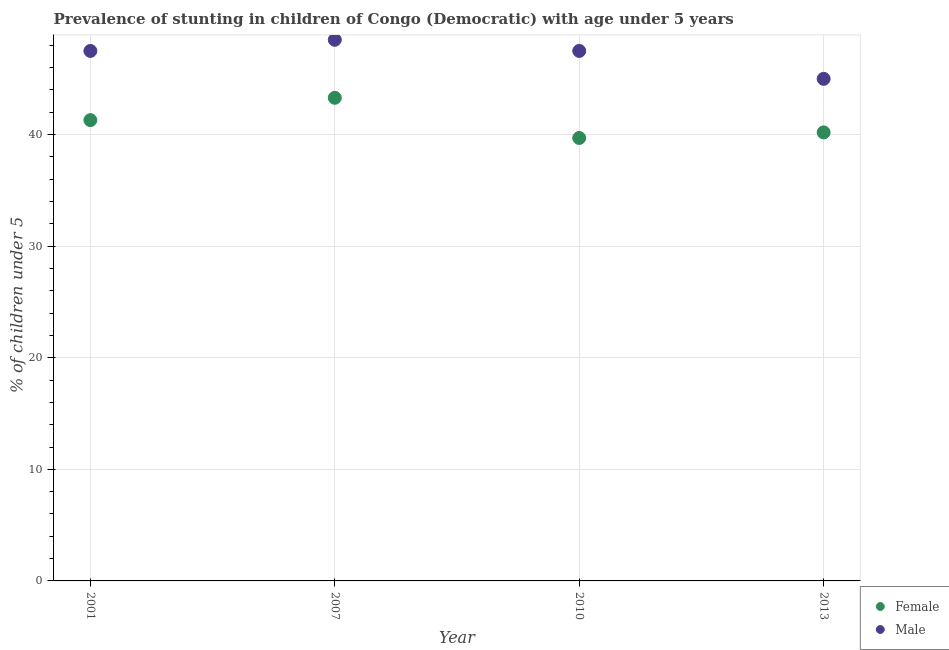How many different coloured dotlines are there?
Your response must be concise. 2. What is the percentage of stunted female children in 2001?
Give a very brief answer. 41.3. Across all years, what is the maximum percentage of stunted female children?
Your answer should be compact. 43.3. Across all years, what is the minimum percentage of stunted female children?
Keep it short and to the point. 39.7. In which year was the percentage of stunted female children maximum?
Your response must be concise. 2007. What is the total percentage of stunted male children in the graph?
Ensure brevity in your answer.  188.5. What is the difference between the percentage of stunted male children in 2007 and the percentage of stunted female children in 2010?
Offer a terse response. 8.8. What is the average percentage of stunted female children per year?
Ensure brevity in your answer.  41.12. In the year 2013, what is the difference between the percentage of stunted male children and percentage of stunted female children?
Ensure brevity in your answer.  4.8. What is the ratio of the percentage of stunted male children in 2007 to that in 2013?
Your answer should be very brief. 1.08. What is the difference between the highest and the second highest percentage of stunted female children?
Provide a succinct answer. 2. What is the difference between the highest and the lowest percentage of stunted male children?
Provide a succinct answer. 3.5. Is the sum of the percentage of stunted female children in 2010 and 2013 greater than the maximum percentage of stunted male children across all years?
Your answer should be compact. Yes. Does the percentage of stunted female children monotonically increase over the years?
Give a very brief answer. No. Is the percentage of stunted male children strictly greater than the percentage of stunted female children over the years?
Offer a very short reply. Yes. How many years are there in the graph?
Offer a terse response. 4. What is the difference between two consecutive major ticks on the Y-axis?
Offer a very short reply. 10. Does the graph contain grids?
Your answer should be very brief. Yes. Where does the legend appear in the graph?
Ensure brevity in your answer.  Bottom right. How are the legend labels stacked?
Your answer should be very brief. Vertical. What is the title of the graph?
Your answer should be compact. Prevalence of stunting in children of Congo (Democratic) with age under 5 years. What is the label or title of the Y-axis?
Keep it short and to the point.  % of children under 5. What is the  % of children under 5 in Female in 2001?
Provide a short and direct response. 41.3. What is the  % of children under 5 in Male in 2001?
Keep it short and to the point. 47.5. What is the  % of children under 5 of Female in 2007?
Make the answer very short. 43.3. What is the  % of children under 5 of Male in 2007?
Your answer should be very brief. 48.5. What is the  % of children under 5 in Female in 2010?
Your answer should be very brief. 39.7. What is the  % of children under 5 in Male in 2010?
Keep it short and to the point. 47.5. What is the  % of children under 5 of Female in 2013?
Keep it short and to the point. 40.2. What is the  % of children under 5 of Male in 2013?
Your answer should be very brief. 45. Across all years, what is the maximum  % of children under 5 in Female?
Offer a very short reply. 43.3. Across all years, what is the maximum  % of children under 5 of Male?
Offer a very short reply. 48.5. Across all years, what is the minimum  % of children under 5 of Female?
Make the answer very short. 39.7. Across all years, what is the minimum  % of children under 5 of Male?
Offer a very short reply. 45. What is the total  % of children under 5 of Female in the graph?
Your answer should be compact. 164.5. What is the total  % of children under 5 in Male in the graph?
Provide a short and direct response. 188.5. What is the difference between the  % of children under 5 of Female in 2001 and that in 2007?
Your answer should be very brief. -2. What is the difference between the  % of children under 5 of Male in 2001 and that in 2010?
Your response must be concise. 0. What is the difference between the  % of children under 5 in Female in 2001 and that in 2013?
Provide a short and direct response. 1.1. What is the difference between the  % of children under 5 in Male in 2007 and that in 2010?
Keep it short and to the point. 1. What is the difference between the  % of children under 5 of Female in 2007 and that in 2013?
Keep it short and to the point. 3.1. What is the difference between the  % of children under 5 in Male in 2007 and that in 2013?
Make the answer very short. 3.5. What is the difference between the  % of children under 5 of Female in 2010 and that in 2013?
Your response must be concise. -0.5. What is the difference between the  % of children under 5 in Female in 2001 and the  % of children under 5 in Male in 2013?
Provide a short and direct response. -3.7. What is the difference between the  % of children under 5 of Female in 2007 and the  % of children under 5 of Male in 2010?
Your answer should be compact. -4.2. What is the average  % of children under 5 of Female per year?
Your answer should be very brief. 41.12. What is the average  % of children under 5 in Male per year?
Offer a very short reply. 47.12. In the year 2001, what is the difference between the  % of children under 5 in Female and  % of children under 5 in Male?
Your answer should be very brief. -6.2. In the year 2010, what is the difference between the  % of children under 5 of Female and  % of children under 5 of Male?
Ensure brevity in your answer.  -7.8. What is the ratio of the  % of children under 5 of Female in 2001 to that in 2007?
Keep it short and to the point. 0.95. What is the ratio of the  % of children under 5 of Male in 2001 to that in 2007?
Offer a terse response. 0.98. What is the ratio of the  % of children under 5 in Female in 2001 to that in 2010?
Make the answer very short. 1.04. What is the ratio of the  % of children under 5 in Female in 2001 to that in 2013?
Give a very brief answer. 1.03. What is the ratio of the  % of children under 5 of Male in 2001 to that in 2013?
Your answer should be compact. 1.06. What is the ratio of the  % of children under 5 of Female in 2007 to that in 2010?
Your response must be concise. 1.09. What is the ratio of the  % of children under 5 of Male in 2007 to that in 2010?
Offer a very short reply. 1.02. What is the ratio of the  % of children under 5 of Female in 2007 to that in 2013?
Your answer should be compact. 1.08. What is the ratio of the  % of children under 5 in Male in 2007 to that in 2013?
Your response must be concise. 1.08. What is the ratio of the  % of children under 5 in Female in 2010 to that in 2013?
Offer a very short reply. 0.99. What is the ratio of the  % of children under 5 in Male in 2010 to that in 2013?
Offer a terse response. 1.06. What is the difference between the highest and the second highest  % of children under 5 of Male?
Make the answer very short. 1. What is the difference between the highest and the lowest  % of children under 5 of Female?
Offer a very short reply. 3.6. 